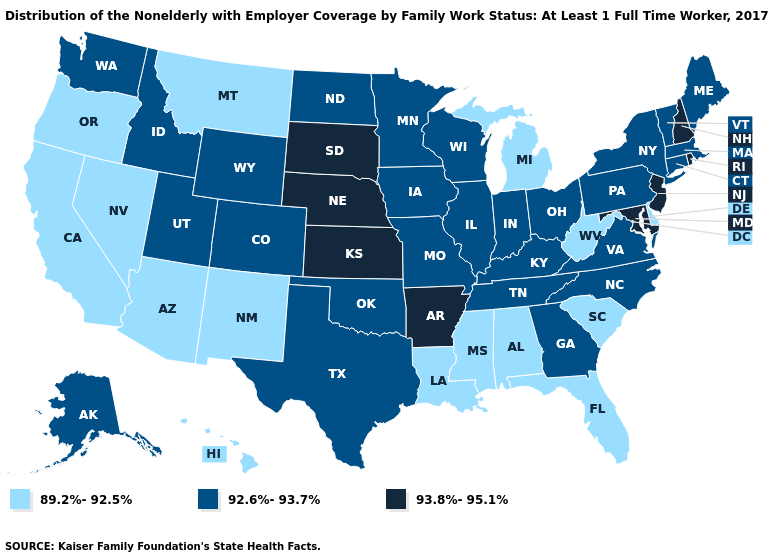Does Alabama have the same value as North Dakota?
Concise answer only. No. Name the states that have a value in the range 89.2%-92.5%?
Answer briefly. Alabama, Arizona, California, Delaware, Florida, Hawaii, Louisiana, Michigan, Mississippi, Montana, Nevada, New Mexico, Oregon, South Carolina, West Virginia. What is the value of Colorado?
Give a very brief answer. 92.6%-93.7%. Does New Jersey have the lowest value in the Northeast?
Give a very brief answer. No. Does Florida have the lowest value in the USA?
Quick response, please. Yes. Which states have the lowest value in the USA?
Keep it brief. Alabama, Arizona, California, Delaware, Florida, Hawaii, Louisiana, Michigan, Mississippi, Montana, Nevada, New Mexico, Oregon, South Carolina, West Virginia. Name the states that have a value in the range 89.2%-92.5%?
Give a very brief answer. Alabama, Arizona, California, Delaware, Florida, Hawaii, Louisiana, Michigan, Mississippi, Montana, Nevada, New Mexico, Oregon, South Carolina, West Virginia. Name the states that have a value in the range 93.8%-95.1%?
Be succinct. Arkansas, Kansas, Maryland, Nebraska, New Hampshire, New Jersey, Rhode Island, South Dakota. Does Connecticut have a lower value than Rhode Island?
Write a very short answer. Yes. Among the states that border Kentucky , which have the lowest value?
Quick response, please. West Virginia. What is the value of Utah?
Write a very short answer. 92.6%-93.7%. How many symbols are there in the legend?
Short answer required. 3. What is the lowest value in states that border Maine?
Quick response, please. 93.8%-95.1%. What is the lowest value in the MidWest?
Quick response, please. 89.2%-92.5%. What is the value of Florida?
Concise answer only. 89.2%-92.5%. 